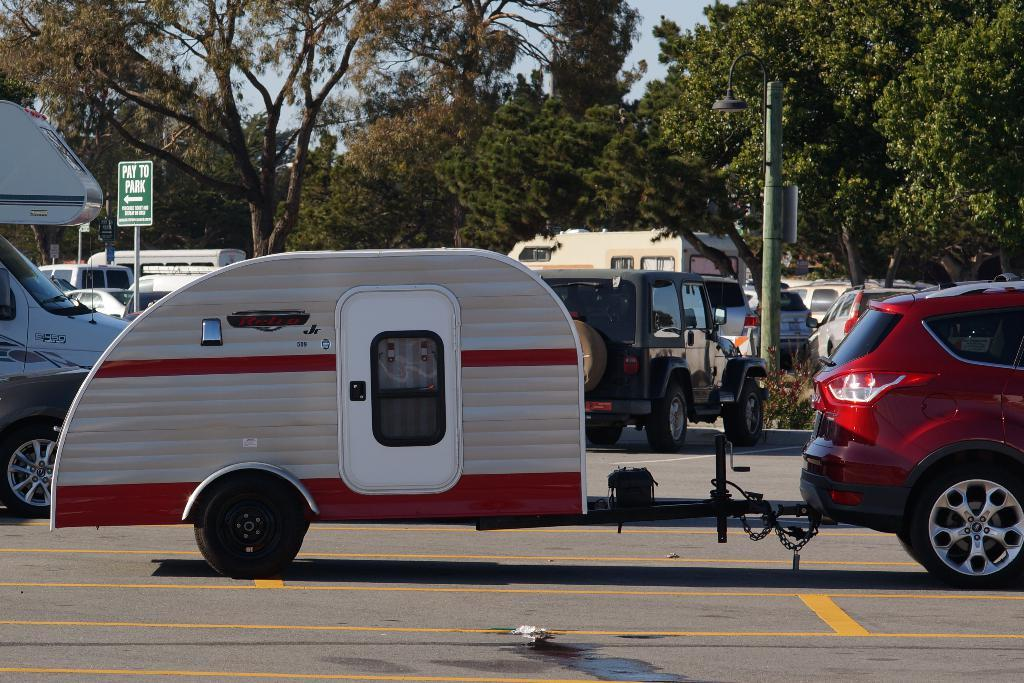<image>
Relay a brief, clear account of the picture shown. Green sign on a street which says PAY TO PARK. 